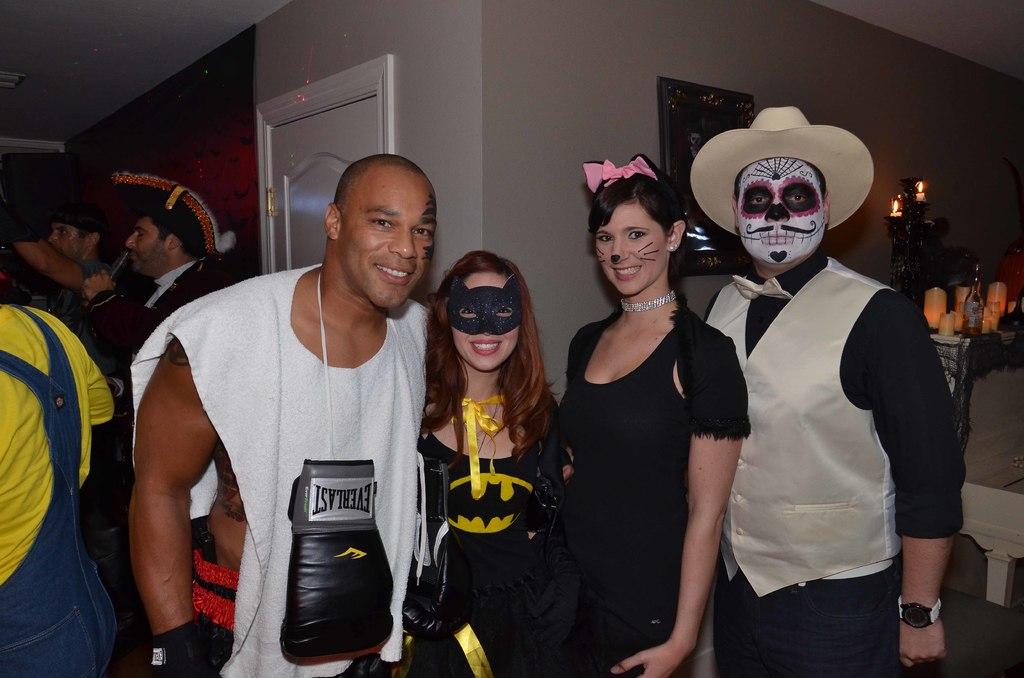What is the brand of boxing gloves?
Provide a short and direct response. Everlast. 